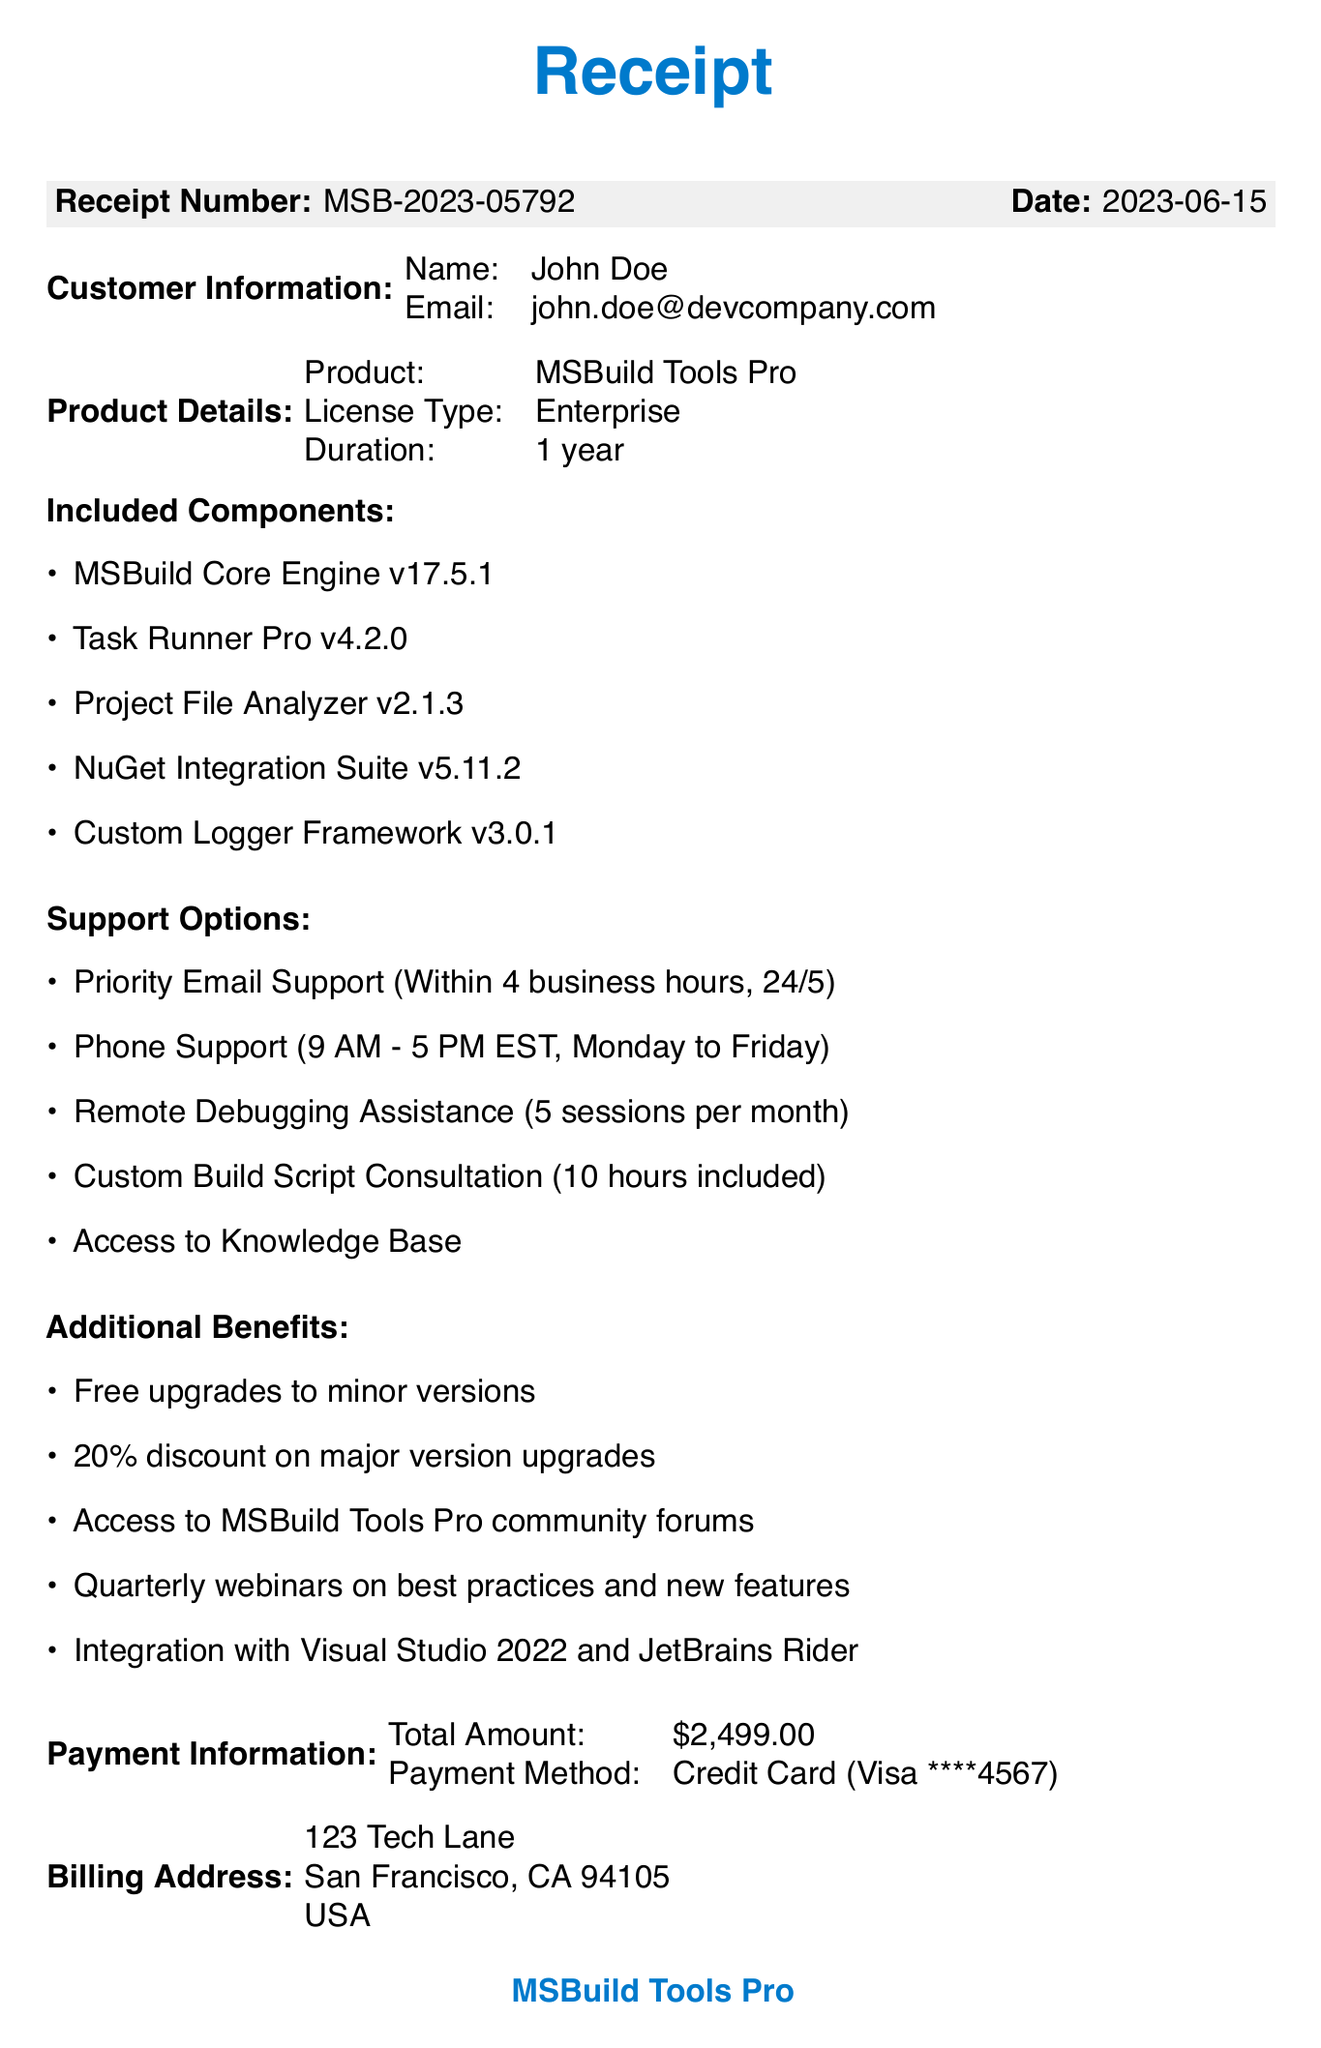What is the receipt number? The receipt number is a unique identifier for the transaction, which is stated in the document.
Answer: MSB-2023-05792 What is the customer name? The name of the customer who made the purchase is specified in the document.
Answer: John Doe How long is the license duration? The license duration indicates the period for which the license is valid, mentioned in the document.
Answer: 1 year What is the total amount charged? The total amount represents the overall cost of the product purchased, detailed in the receipt.
Answer: $2,499.00 What is included in the support options? The support options detail the types of assistance available to the customer, listed in the document.
Answer: Priority Email Support How many sessions of Remote Debugging Assistance are included? This specifies the maximum number of assistance sessions available monthly, derived from the document.
Answer: 5 sessions What is the card type used for payment? The card type indicates the brand of the credit card used for the transaction, as mentioned in the payment section.
Answer: Visa What is the address for billing? The billing address is the location associated with the payment method, which is noted in the document.
Answer: 123 Tech Lane, San Francisco, CA 94105, USA What is one of the additional benefits included? Additional benefits are perks offered to the customer, showcased at the end of the receipt.
Answer: Free upgrades to minor versions 